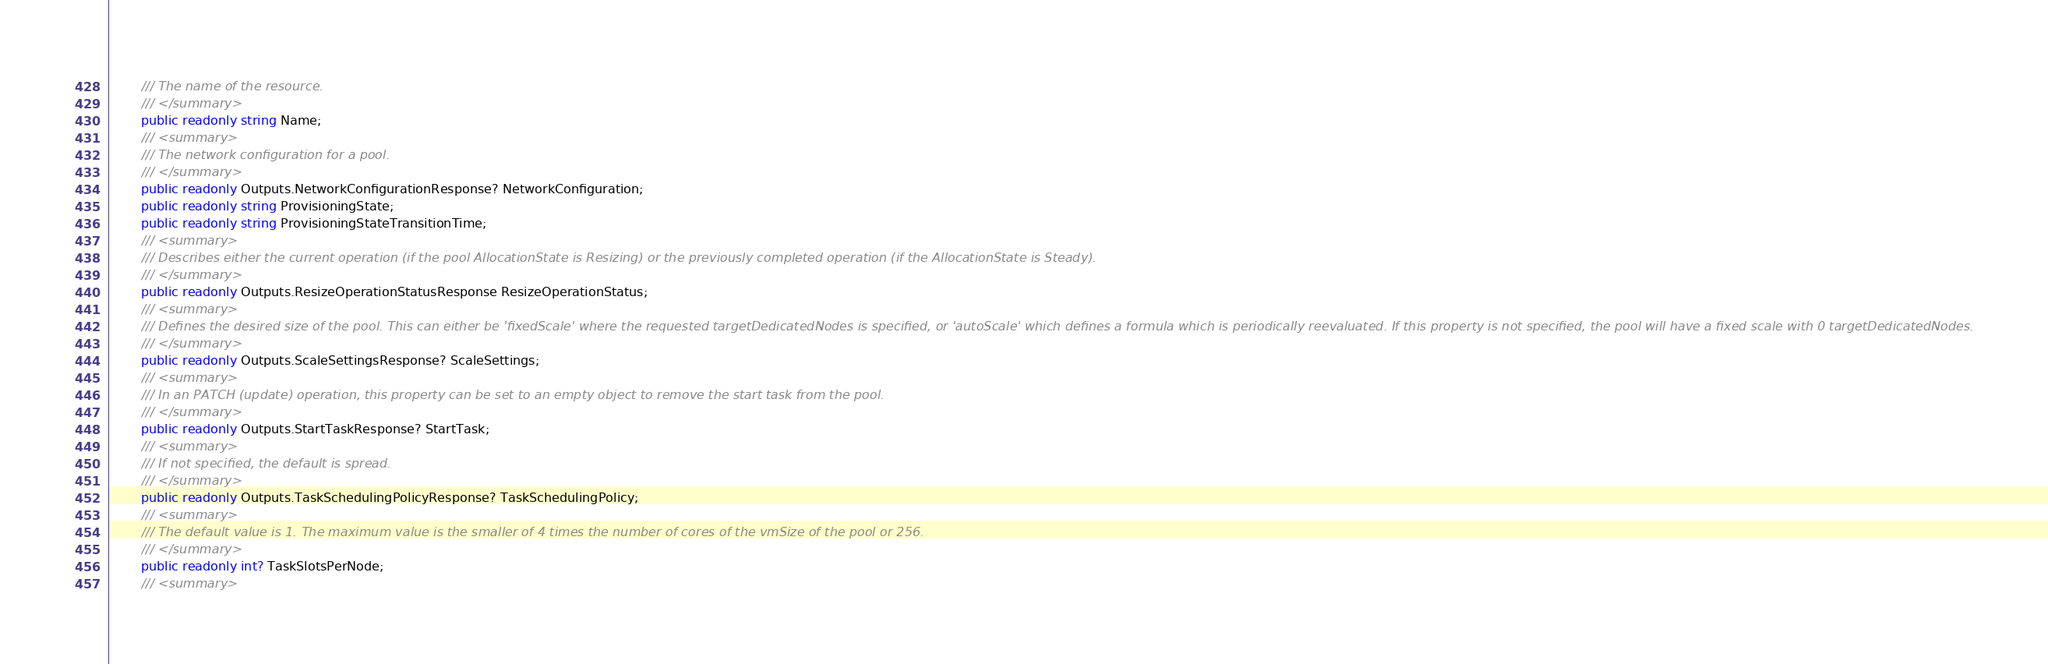Convert code to text. <code><loc_0><loc_0><loc_500><loc_500><_C#_>        /// The name of the resource.
        /// </summary>
        public readonly string Name;
        /// <summary>
        /// The network configuration for a pool.
        /// </summary>
        public readonly Outputs.NetworkConfigurationResponse? NetworkConfiguration;
        public readonly string ProvisioningState;
        public readonly string ProvisioningStateTransitionTime;
        /// <summary>
        /// Describes either the current operation (if the pool AllocationState is Resizing) or the previously completed operation (if the AllocationState is Steady).
        /// </summary>
        public readonly Outputs.ResizeOperationStatusResponse ResizeOperationStatus;
        /// <summary>
        /// Defines the desired size of the pool. This can either be 'fixedScale' where the requested targetDedicatedNodes is specified, or 'autoScale' which defines a formula which is periodically reevaluated. If this property is not specified, the pool will have a fixed scale with 0 targetDedicatedNodes.
        /// </summary>
        public readonly Outputs.ScaleSettingsResponse? ScaleSettings;
        /// <summary>
        /// In an PATCH (update) operation, this property can be set to an empty object to remove the start task from the pool.
        /// </summary>
        public readonly Outputs.StartTaskResponse? StartTask;
        /// <summary>
        /// If not specified, the default is spread.
        /// </summary>
        public readonly Outputs.TaskSchedulingPolicyResponse? TaskSchedulingPolicy;
        /// <summary>
        /// The default value is 1. The maximum value is the smaller of 4 times the number of cores of the vmSize of the pool or 256.
        /// </summary>
        public readonly int? TaskSlotsPerNode;
        /// <summary></code> 